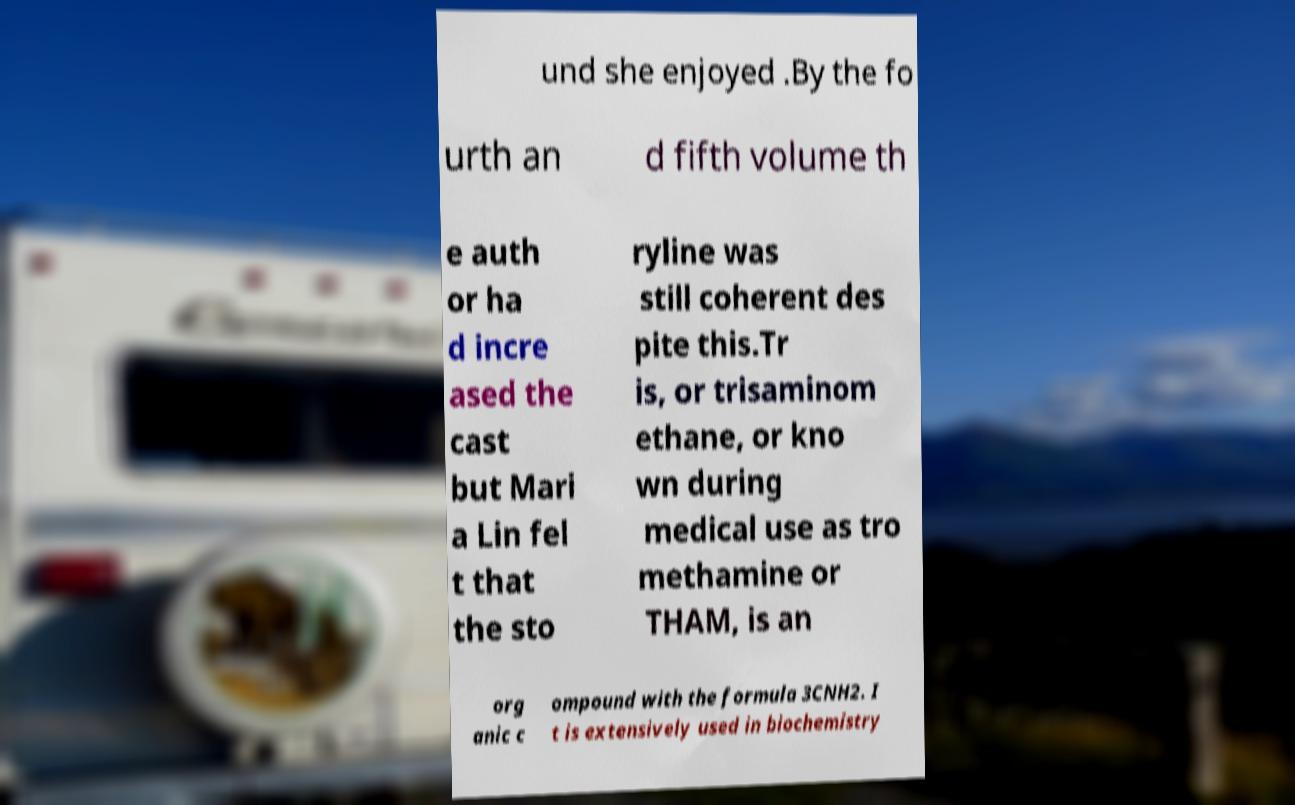Could you assist in decoding the text presented in this image and type it out clearly? und she enjoyed .By the fo urth an d fifth volume th e auth or ha d incre ased the cast but Mari a Lin fel t that the sto ryline was still coherent des pite this.Tr is, or trisaminom ethane, or kno wn during medical use as tro methamine or THAM, is an org anic c ompound with the formula 3CNH2. I t is extensively used in biochemistry 